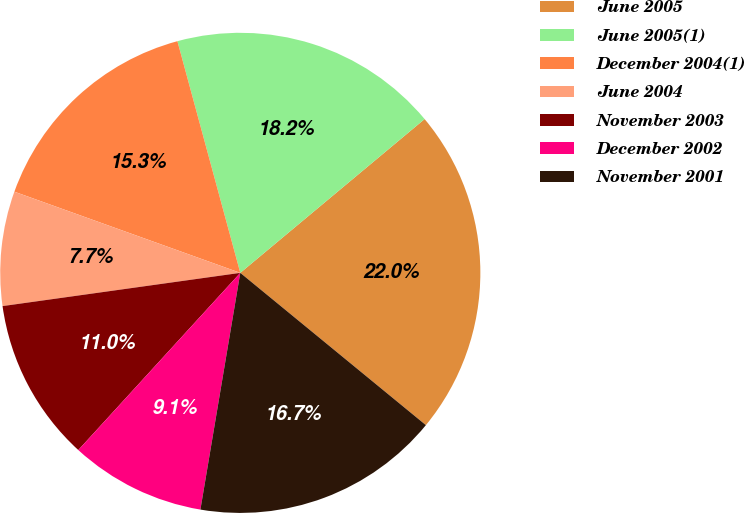Convert chart to OTSL. <chart><loc_0><loc_0><loc_500><loc_500><pie_chart><fcel>June 2005<fcel>June 2005(1)<fcel>December 2004(1)<fcel>June 2004<fcel>November 2003<fcel>December 2002<fcel>November 2001<nl><fcel>22.0%<fcel>18.15%<fcel>15.29%<fcel>7.7%<fcel>11.0%<fcel>9.13%<fcel>16.72%<nl></chart> 